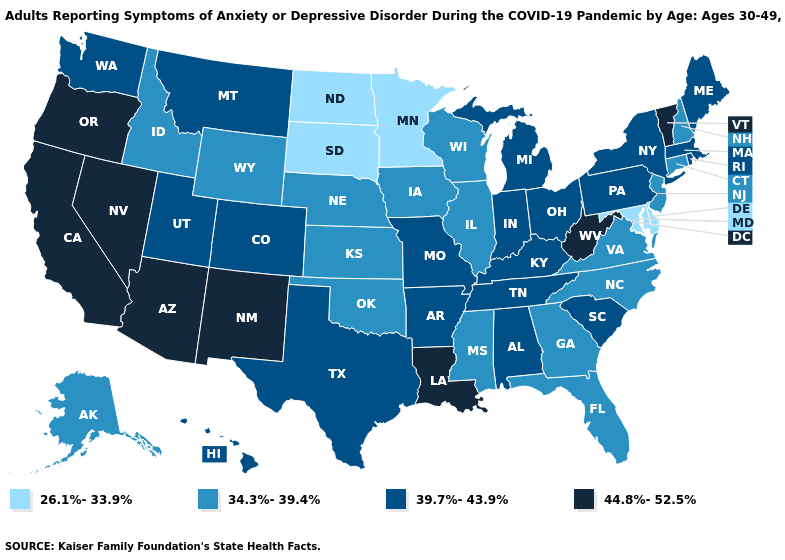What is the value of Mississippi?
Write a very short answer. 34.3%-39.4%. What is the lowest value in the South?
Give a very brief answer. 26.1%-33.9%. Name the states that have a value in the range 26.1%-33.9%?
Short answer required. Delaware, Maryland, Minnesota, North Dakota, South Dakota. Name the states that have a value in the range 39.7%-43.9%?
Keep it brief. Alabama, Arkansas, Colorado, Hawaii, Indiana, Kentucky, Maine, Massachusetts, Michigan, Missouri, Montana, New York, Ohio, Pennsylvania, Rhode Island, South Carolina, Tennessee, Texas, Utah, Washington. What is the value of Indiana?
Give a very brief answer. 39.7%-43.9%. Among the states that border Ohio , which have the lowest value?
Keep it brief. Indiana, Kentucky, Michigan, Pennsylvania. Among the states that border Kansas , does Colorado have the highest value?
Give a very brief answer. Yes. Among the states that border Wisconsin , does Michigan have the lowest value?
Be succinct. No. Among the states that border Virginia , which have the lowest value?
Write a very short answer. Maryland. Is the legend a continuous bar?
Be succinct. No. Is the legend a continuous bar?
Answer briefly. No. Among the states that border Missouri , which have the highest value?
Concise answer only. Arkansas, Kentucky, Tennessee. Among the states that border Ohio , does Indiana have the lowest value?
Write a very short answer. Yes. What is the lowest value in states that border Alabama?
Keep it brief. 34.3%-39.4%. Name the states that have a value in the range 44.8%-52.5%?
Concise answer only. Arizona, California, Louisiana, Nevada, New Mexico, Oregon, Vermont, West Virginia. 